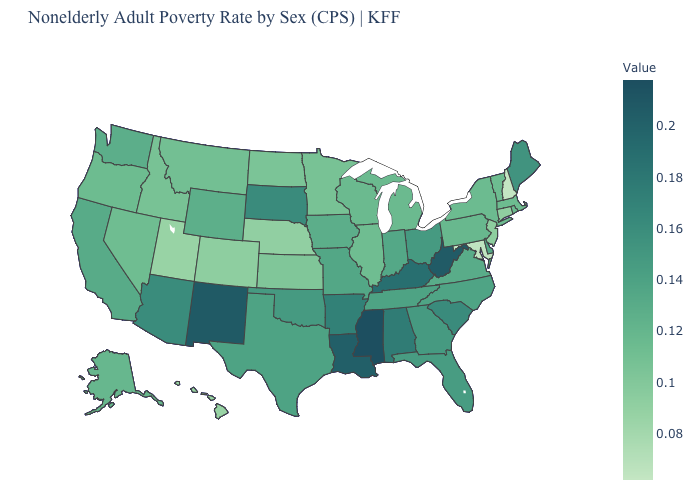Among the states that border South Dakota , which have the highest value?
Be succinct. Iowa. Among the states that border Iowa , does South Dakota have the highest value?
Answer briefly. Yes. Among the states that border Oklahoma , does Arkansas have the lowest value?
Answer briefly. No. Does New Hampshire have the lowest value in the USA?
Write a very short answer. Yes. Does South Dakota have the highest value in the MidWest?
Short answer required. Yes. Does Iowa have a higher value than Utah?
Concise answer only. Yes. 